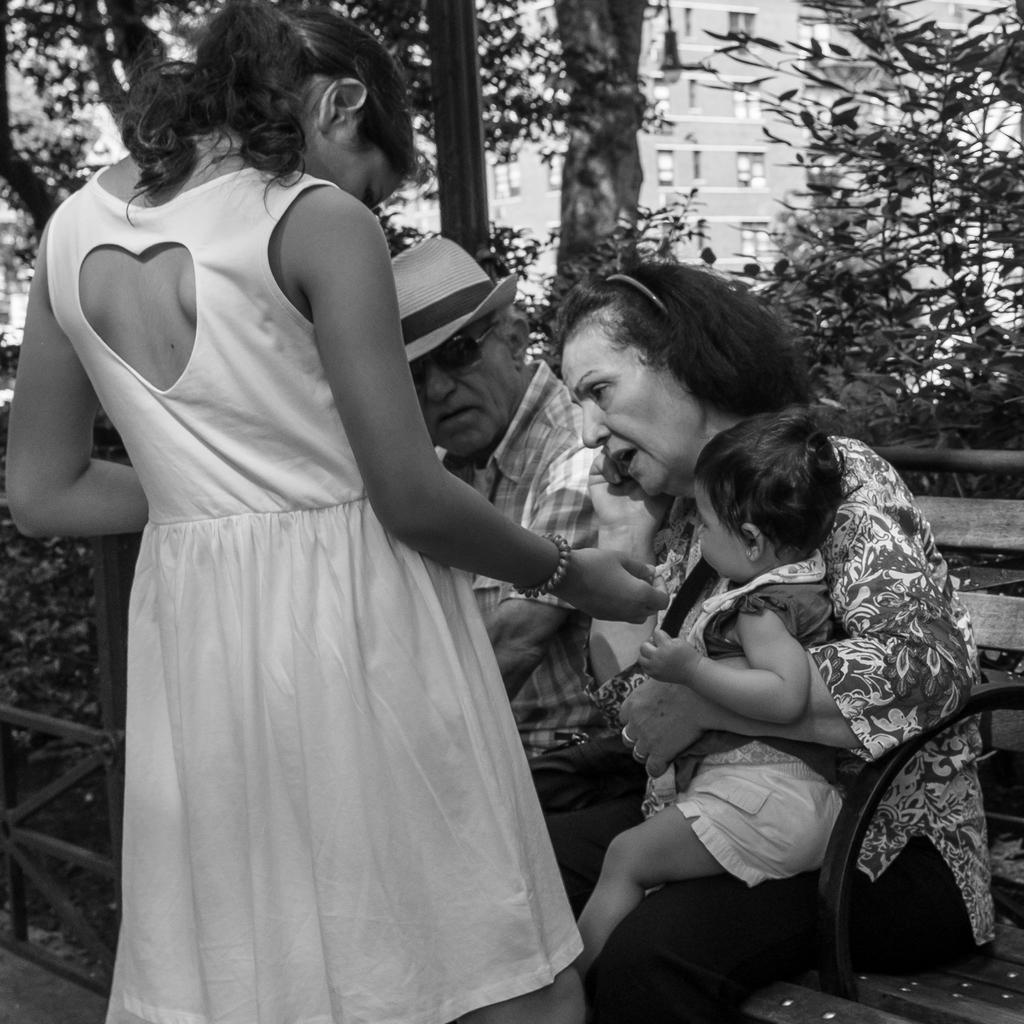How many people are in the image? There is a group of people in the image. What are some of the people in the image doing? Some people are seated on a bench, while a woman is standing in the image. What can be seen in the background of the image? There are trees and buildings visible in the background. How many cars can be seen in the image? There are no cars visible in the image. What is the woman in the image laughing at? There is no indication in the image that the woman is laughing, so it cannot be determined from the picture. 